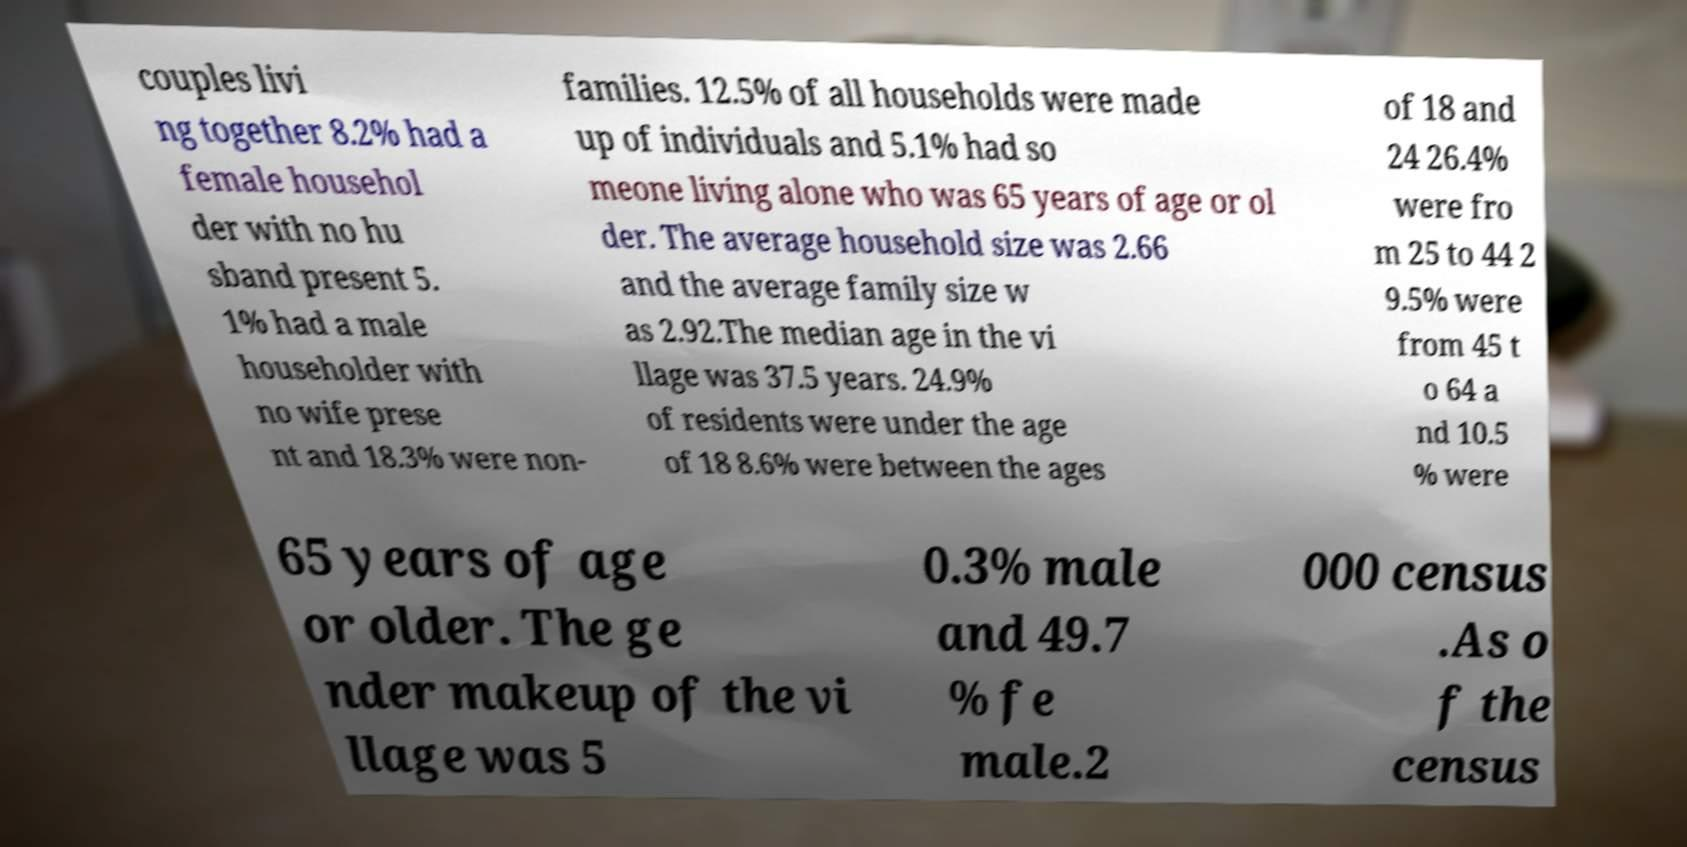Can you accurately transcribe the text from the provided image for me? couples livi ng together 8.2% had a female househol der with no hu sband present 5. 1% had a male householder with no wife prese nt and 18.3% were non- families. 12.5% of all households were made up of individuals and 5.1% had so meone living alone who was 65 years of age or ol der. The average household size was 2.66 and the average family size w as 2.92.The median age in the vi llage was 37.5 years. 24.9% of residents were under the age of 18 8.6% were between the ages of 18 and 24 26.4% were fro m 25 to 44 2 9.5% were from 45 t o 64 a nd 10.5 % were 65 years of age or older. The ge nder makeup of the vi llage was 5 0.3% male and 49.7 % fe male.2 000 census .As o f the census 